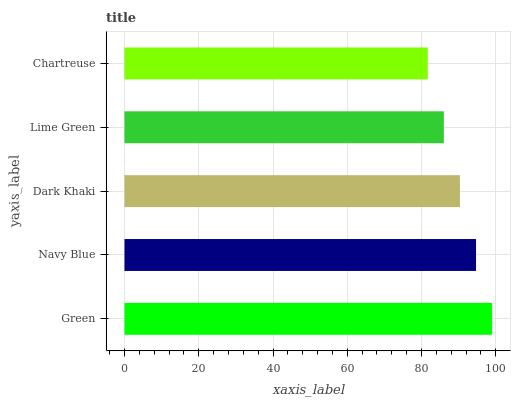Is Chartreuse the minimum?
Answer yes or no. Yes. Is Green the maximum?
Answer yes or no. Yes. Is Navy Blue the minimum?
Answer yes or no. No. Is Navy Blue the maximum?
Answer yes or no. No. Is Green greater than Navy Blue?
Answer yes or no. Yes. Is Navy Blue less than Green?
Answer yes or no. Yes. Is Navy Blue greater than Green?
Answer yes or no. No. Is Green less than Navy Blue?
Answer yes or no. No. Is Dark Khaki the high median?
Answer yes or no. Yes. Is Dark Khaki the low median?
Answer yes or no. Yes. Is Chartreuse the high median?
Answer yes or no. No. Is Lime Green the low median?
Answer yes or no. No. 